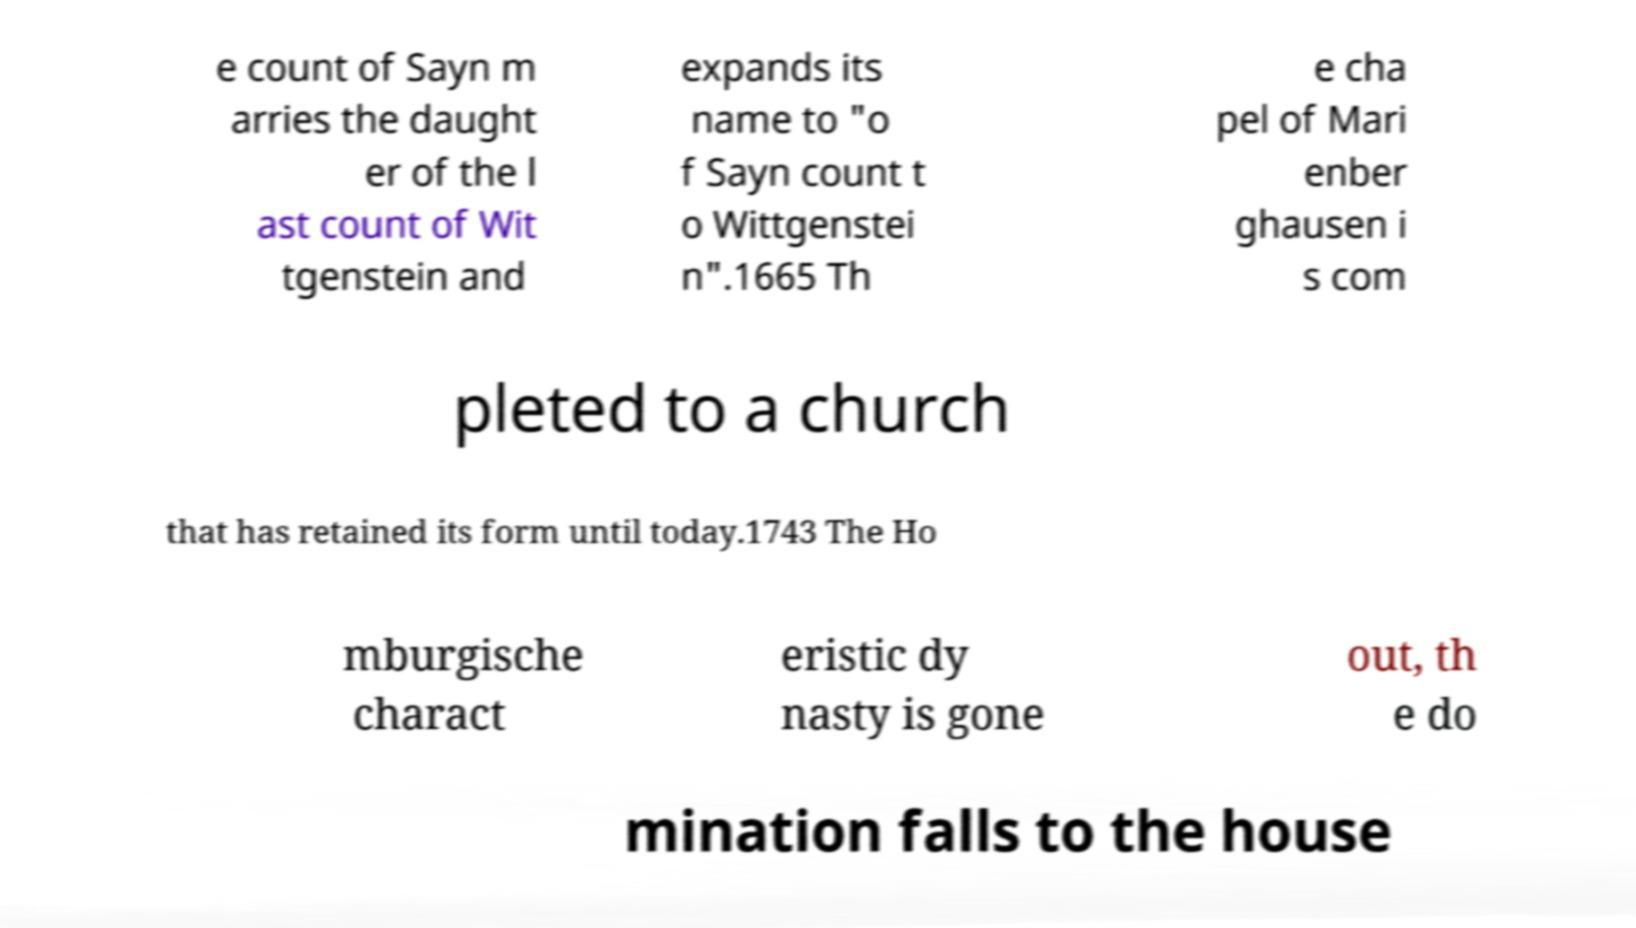For documentation purposes, I need the text within this image transcribed. Could you provide that? e count of Sayn m arries the daught er of the l ast count of Wit tgenstein and expands its name to "o f Sayn count t o Wittgenstei n".1665 Th e cha pel of Mari enber ghausen i s com pleted to a church that has retained its form until today.1743 The Ho mburgische charact eristic dy nasty is gone out, th e do mination falls to the house 